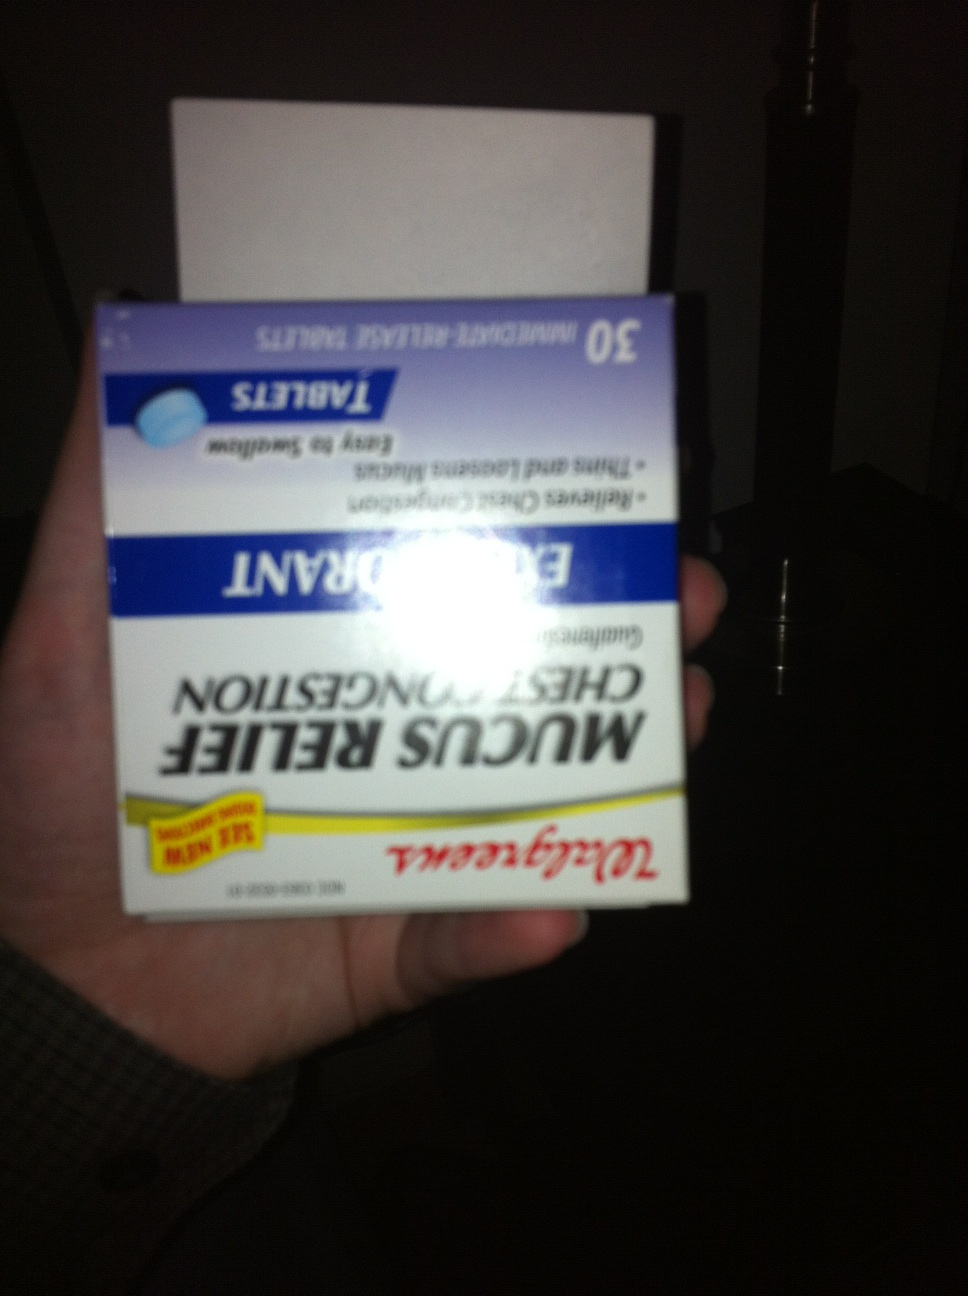What are the active ingredients in this product? The active ingredient in Walgreens Mucus Relief Chest Congestion tablets is Guaifenesin, which is an expectorant. It helps to loosen and thin mucus in the airways, making it easier to cough out through your lungs. How does Guaifenesin work to relieve chest congestion? Guaifenesin works by increasing the volume and reducing the viscosity of secretions in the airways. This helps to loosen mucus and phlegm, making it easier for you to cough it up and clear your airways. As a result, it helps to relieve symptoms of chest congestion and improve breathing. 